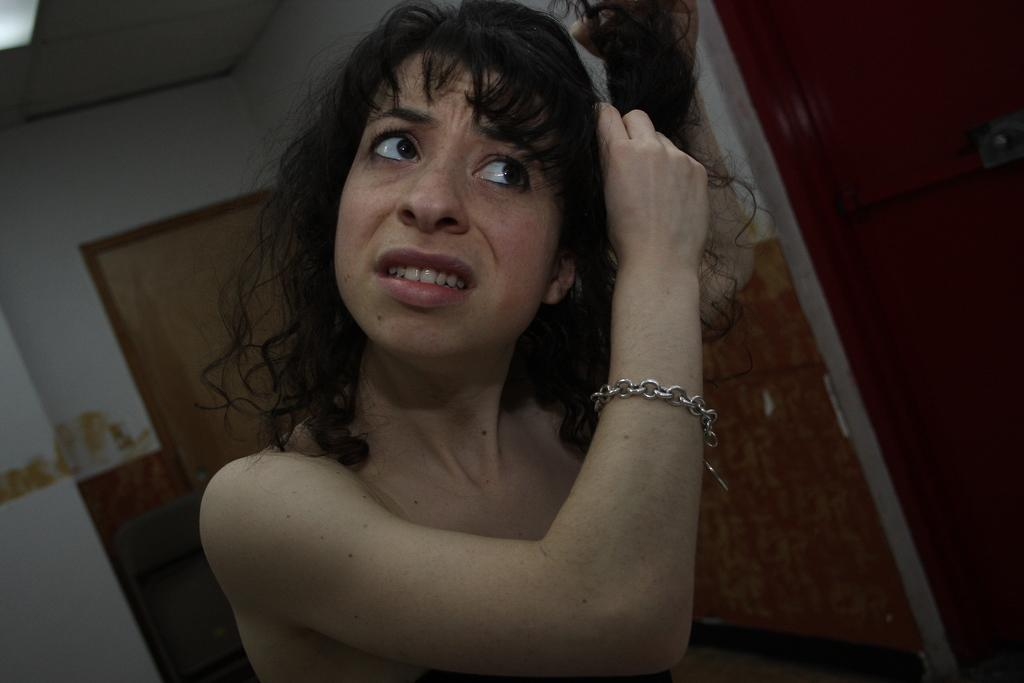Who is present in the image? There is a woman in the image. What is the woman doing with her hair? The woman is holding her hair. What can be seen in the background of the image? There is a wall, a door, and a chair in the background of the image. How many rabbits can be seen in the image? There are no rabbits present in the image. What does the woman in the image hate? The image does not provide any information about the woman's feelings or emotions, including what she might hate. 